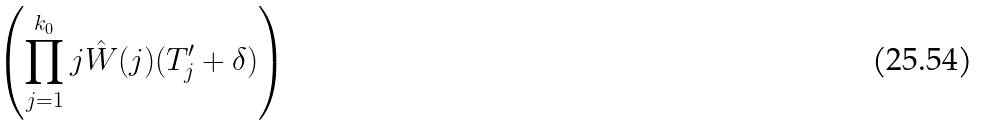Convert formula to latex. <formula><loc_0><loc_0><loc_500><loc_500>\left ( \prod _ { j = 1 } ^ { k _ { 0 } } j \hat { W } ( j ) ( T _ { j } ^ { \prime } + \delta ) \right )</formula> 